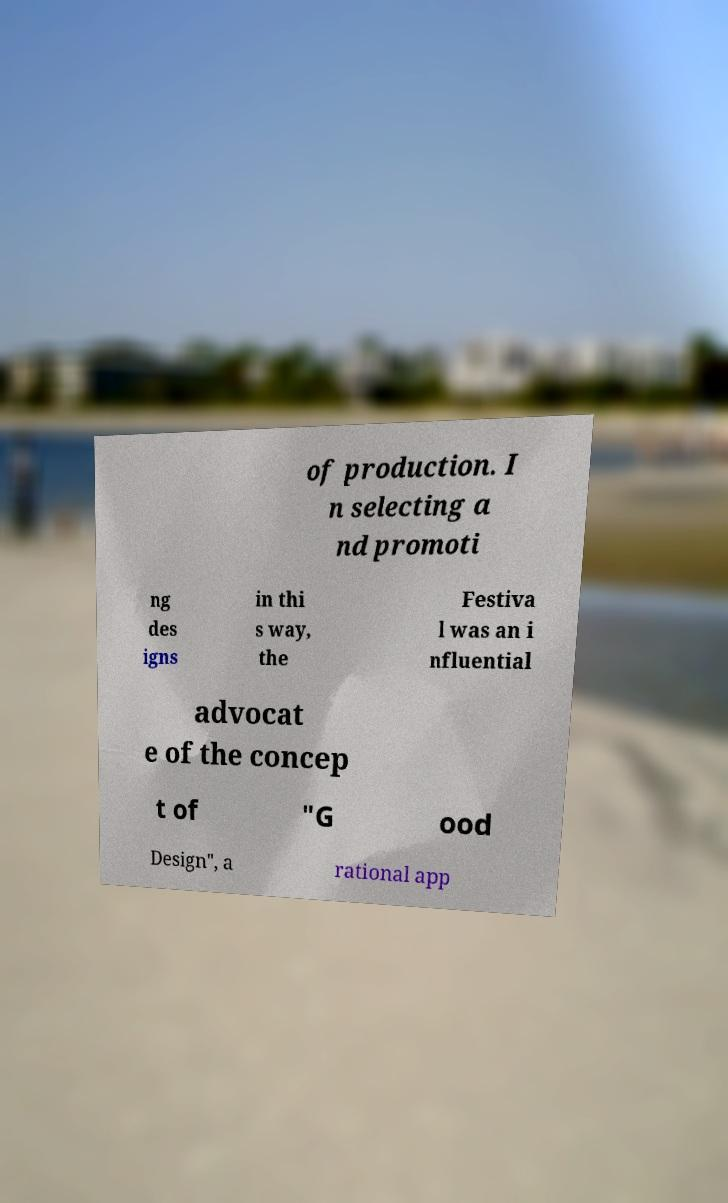Can you read and provide the text displayed in the image?This photo seems to have some interesting text. Can you extract and type it out for me? of production. I n selecting a nd promoti ng des igns in thi s way, the Festiva l was an i nfluential advocat e of the concep t of "G ood Design", a rational app 